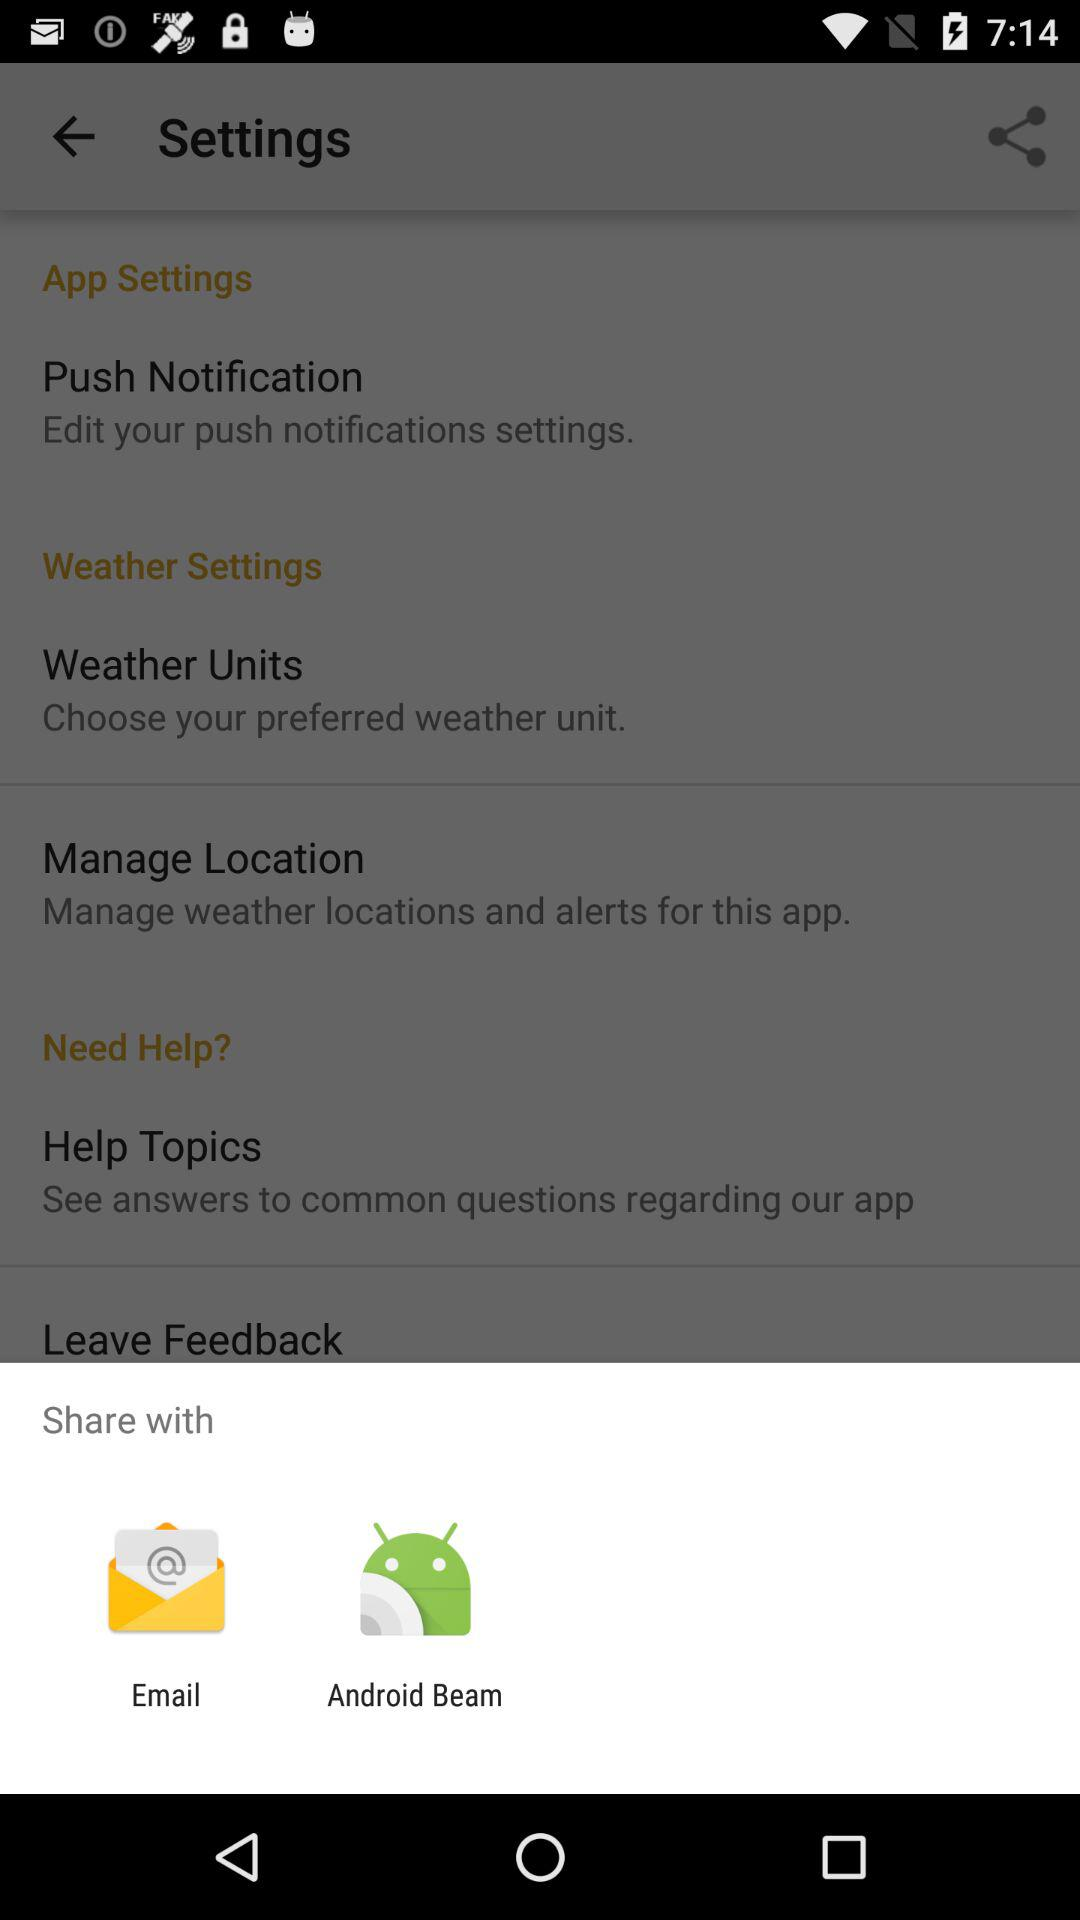What are the sharing options? The sharing options are "Email" and "Android Beam". 